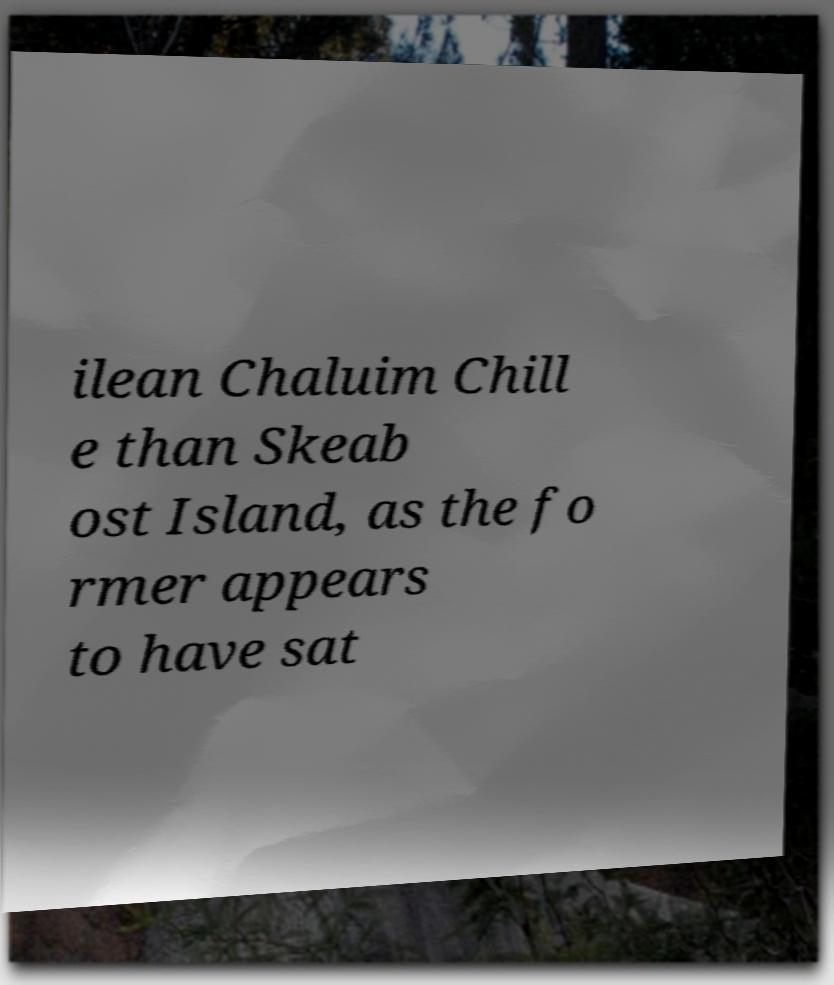Can you read and provide the text displayed in the image?This photo seems to have some interesting text. Can you extract and type it out for me? ilean Chaluim Chill e than Skeab ost Island, as the fo rmer appears to have sat 